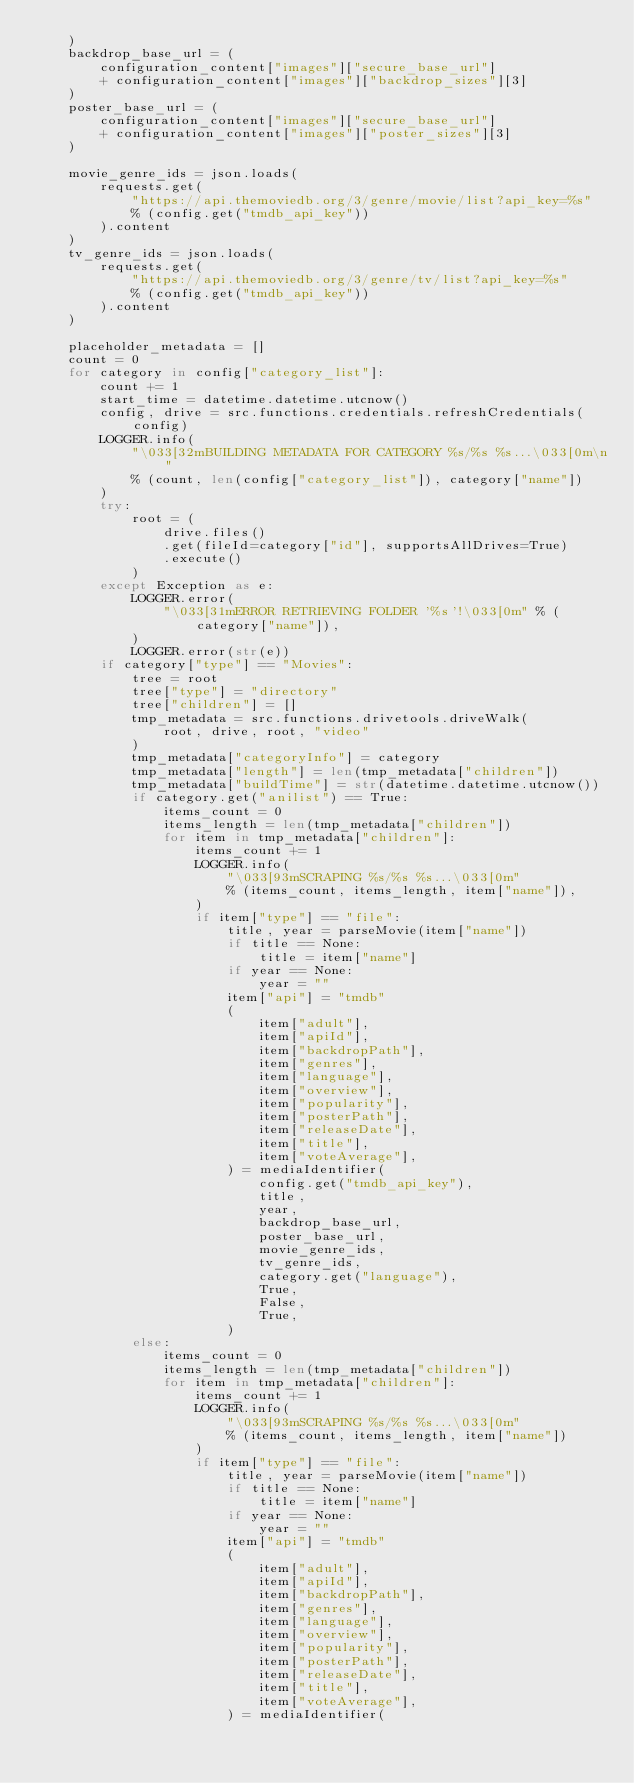<code> <loc_0><loc_0><loc_500><loc_500><_Python_>    )
    backdrop_base_url = (
        configuration_content["images"]["secure_base_url"]
        + configuration_content["images"]["backdrop_sizes"][3]
    )
    poster_base_url = (
        configuration_content["images"]["secure_base_url"]
        + configuration_content["images"]["poster_sizes"][3]
    )

    movie_genre_ids = json.loads(
        requests.get(
            "https://api.themoviedb.org/3/genre/movie/list?api_key=%s"
            % (config.get("tmdb_api_key"))
        ).content
    )
    tv_genre_ids = json.loads(
        requests.get(
            "https://api.themoviedb.org/3/genre/tv/list?api_key=%s"
            % (config.get("tmdb_api_key"))
        ).content
    )

    placeholder_metadata = []
    count = 0
    for category in config["category_list"]:
        count += 1
        start_time = datetime.datetime.utcnow()
        config, drive = src.functions.credentials.refreshCredentials(config)
        LOGGER.info(
            "\033[32mBUILDING METADATA FOR CATEGORY %s/%s %s...\033[0m\n"
            % (count, len(config["category_list"]), category["name"])
        )
        try:
            root = (
                drive.files()
                .get(fileId=category["id"], supportsAllDrives=True)
                .execute()
            )
        except Exception as e:
            LOGGER.error(
                "\033[31mERROR RETRIEVING FOLDER '%s'!\033[0m" % (category["name"]),
            )
            LOGGER.error(str(e))
        if category["type"] == "Movies":
            tree = root
            tree["type"] = "directory"
            tree["children"] = []
            tmp_metadata = src.functions.drivetools.driveWalk(
                root, drive, root, "video"
            )
            tmp_metadata["categoryInfo"] = category
            tmp_metadata["length"] = len(tmp_metadata["children"])
            tmp_metadata["buildTime"] = str(datetime.datetime.utcnow())
            if category.get("anilist") == True:
                items_count = 0
                items_length = len(tmp_metadata["children"])
                for item in tmp_metadata["children"]:
                    items_count += 1
                    LOGGER.info(
                        "\033[93mSCRAPING %s/%s %s...\033[0m"
                        % (items_count, items_length, item["name"]),
                    )
                    if item["type"] == "file":
                        title, year = parseMovie(item["name"])
                        if title == None:
                            title = item["name"]
                        if year == None:
                            year = ""
                        item["api"] = "tmdb"
                        (
                            item["adult"],
                            item["apiId"],
                            item["backdropPath"],
                            item["genres"],
                            item["language"],
                            item["overview"],
                            item["popularity"],
                            item["posterPath"],
                            item["releaseDate"],
                            item["title"],
                            item["voteAverage"],
                        ) = mediaIdentifier(
                            config.get("tmdb_api_key"),
                            title,
                            year,
                            backdrop_base_url,
                            poster_base_url,
                            movie_genre_ids,
                            tv_genre_ids,
                            category.get("language"),
                            True,
                            False,
                            True,
                        )
            else:
                items_count = 0
                items_length = len(tmp_metadata["children"])
                for item in tmp_metadata["children"]:
                    items_count += 1
                    LOGGER.info(
                        "\033[93mSCRAPING %s/%s %s...\033[0m"
                        % (items_count, items_length, item["name"])
                    )
                    if item["type"] == "file":
                        title, year = parseMovie(item["name"])
                        if title == None:
                            title = item["name"]
                        if year == None:
                            year = ""
                        item["api"] = "tmdb"
                        (
                            item["adult"],
                            item["apiId"],
                            item["backdropPath"],
                            item["genres"],
                            item["language"],
                            item["overview"],
                            item["popularity"],
                            item["posterPath"],
                            item["releaseDate"],
                            item["title"],
                            item["voteAverage"],
                        ) = mediaIdentifier(</code> 